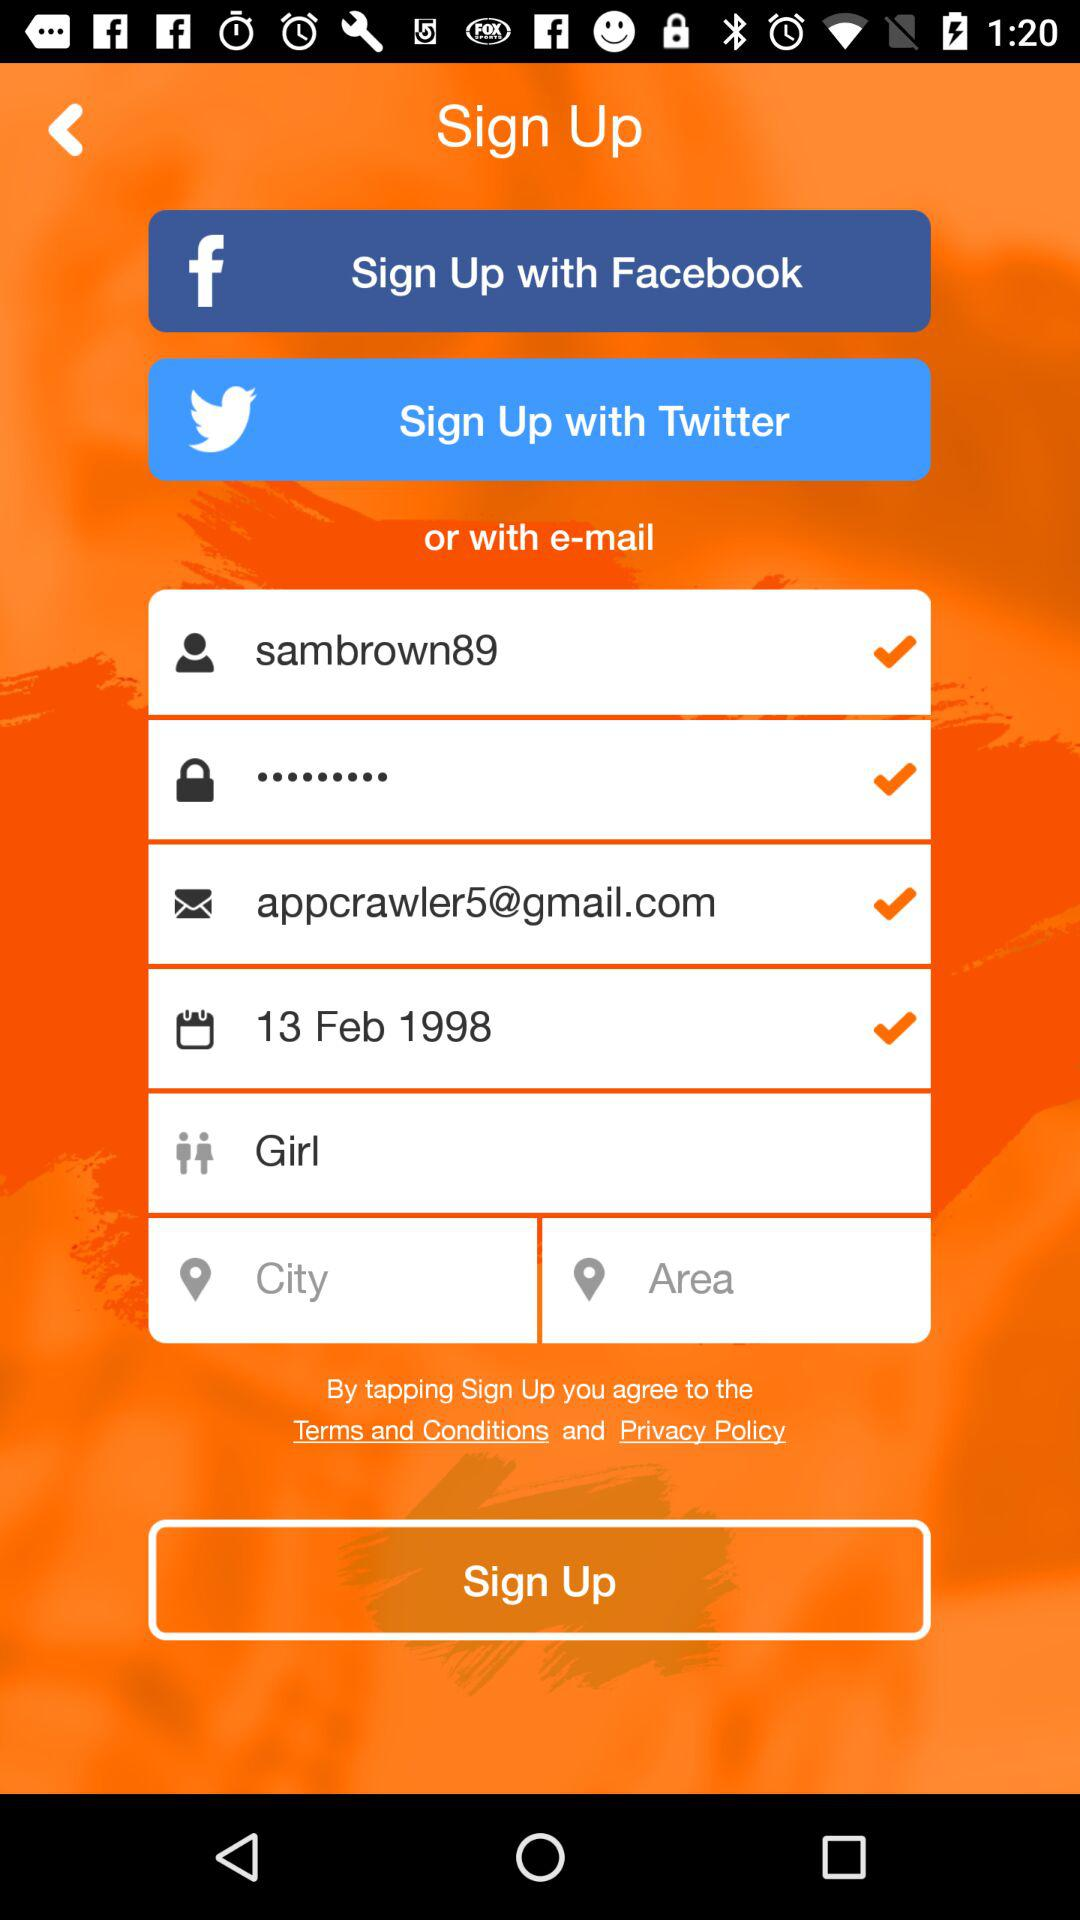What is the gender? The gender is girl. 